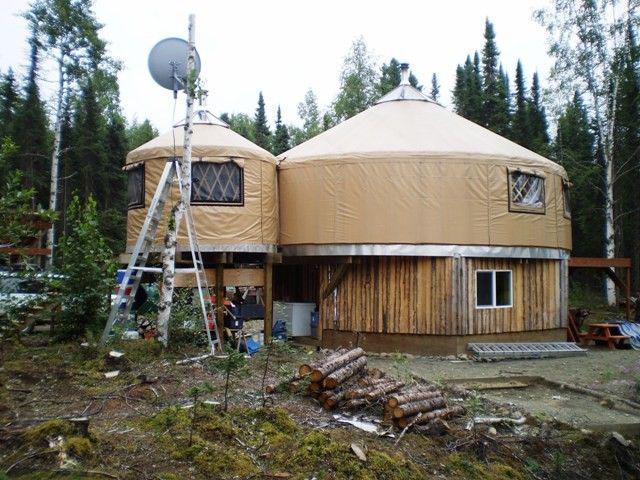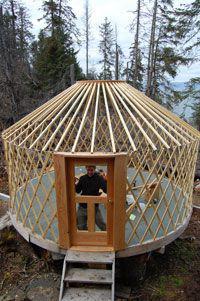The first image is the image on the left, the second image is the image on the right. For the images shown, is this caption "The building is located near trees." true? Answer yes or no. Yes. 